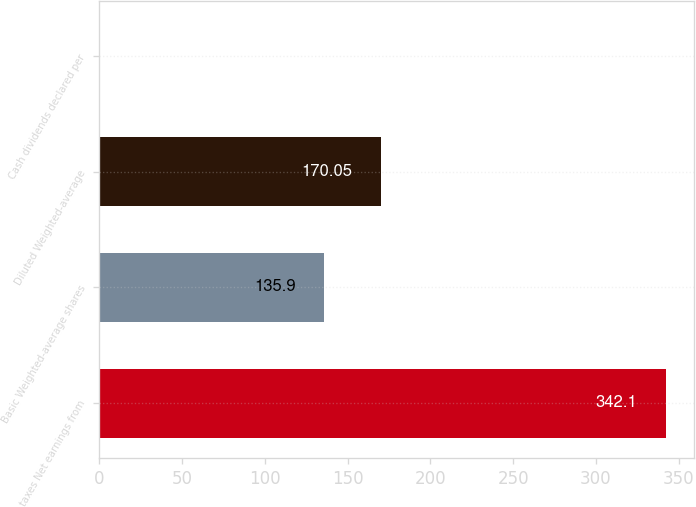Convert chart to OTSL. <chart><loc_0><loc_0><loc_500><loc_500><bar_chart><fcel>taxes Net earnings from<fcel>Basic Weighted-average shares<fcel>Diluted Weighted-average<fcel>Cash dividends declared per<nl><fcel>342.1<fcel>135.9<fcel>170.05<fcel>0.56<nl></chart> 